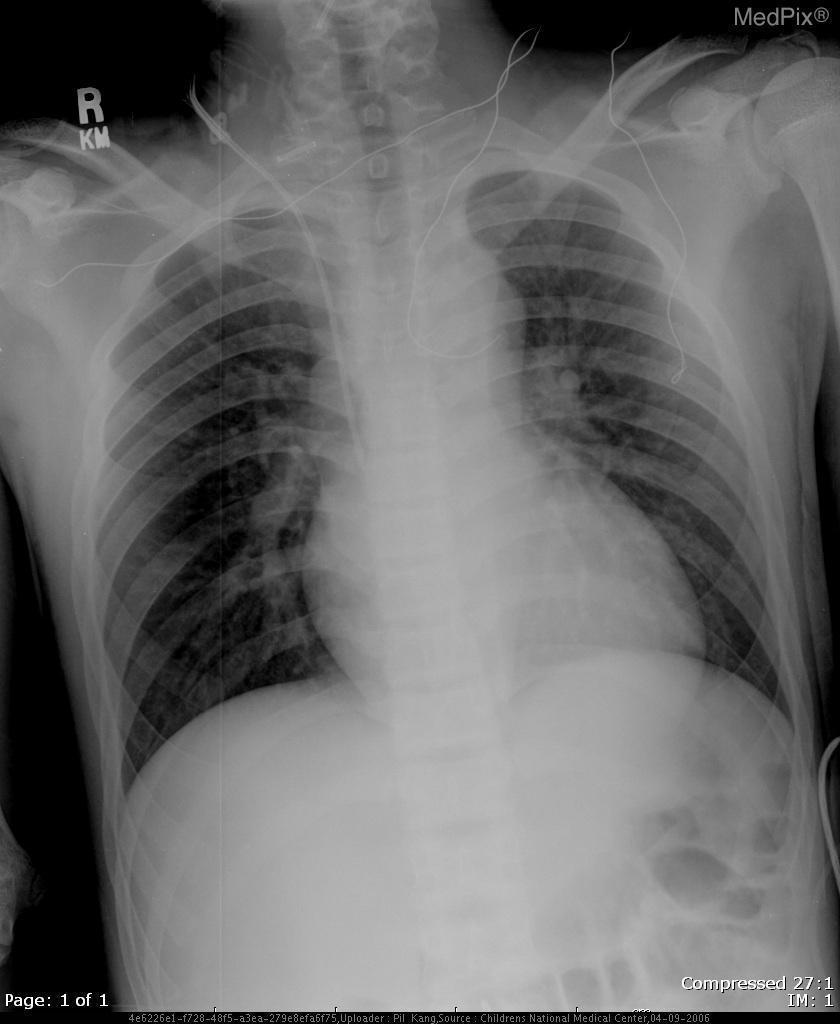Is there fluid in the lungs?
Write a very short answer. No. Is a pleural effusion present?
Short answer required. No. Is cardiomegaly shown?
Keep it brief. Yes. Is the heart enlarged?
Quick response, please. Yes. What imaging modality is used?
Concise answer only. Plain film xray. What is wrong with the aortic area?
Be succinct. It is enlarged with prominence of the aortic knob. What pathology is shown in the aorta?
Answer briefly. It is enlarged with prominence of the aortic knob. 